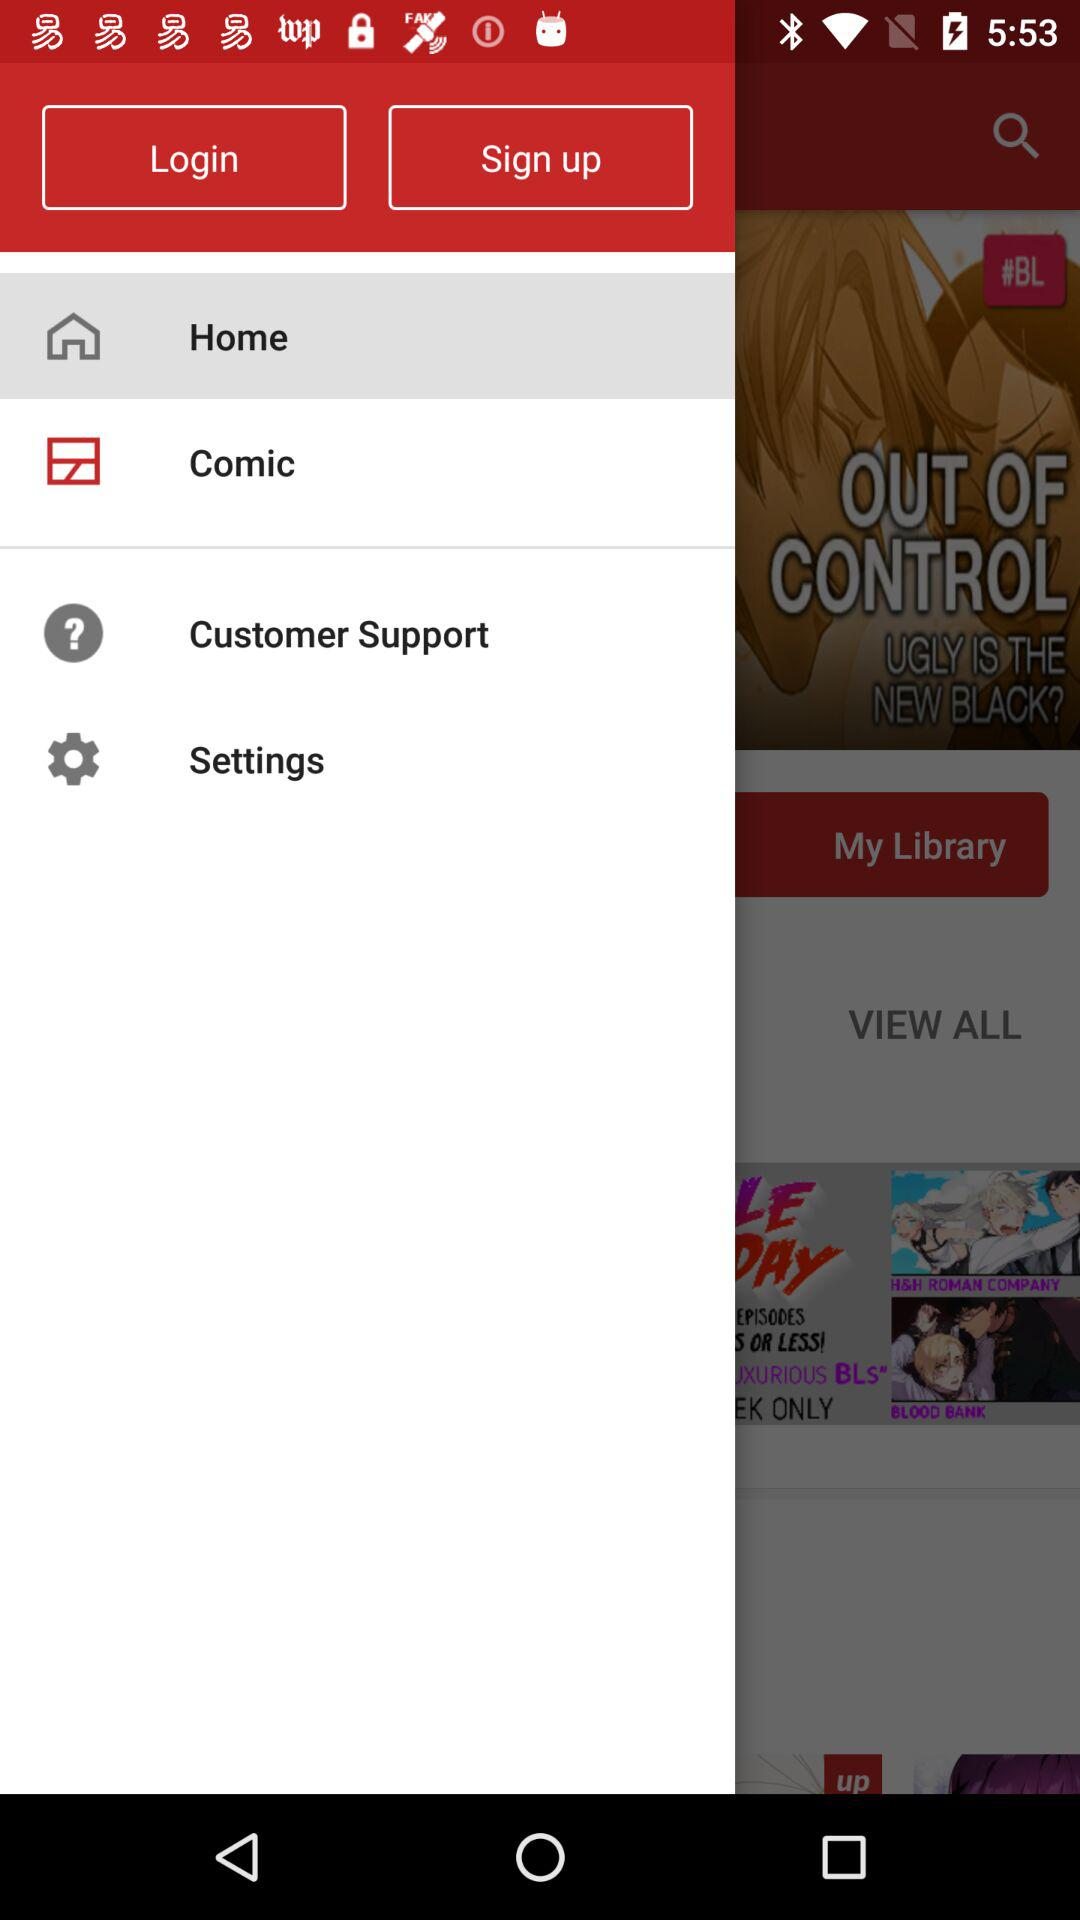What is the selected item? The selected item is "Home". 